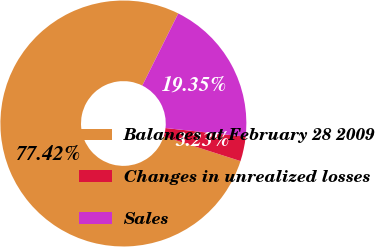Convert chart. <chart><loc_0><loc_0><loc_500><loc_500><pie_chart><fcel>Balances at February 28 2009<fcel>Changes in unrealized losses<fcel>Sales<nl><fcel>77.42%<fcel>3.23%<fcel>19.35%<nl></chart> 